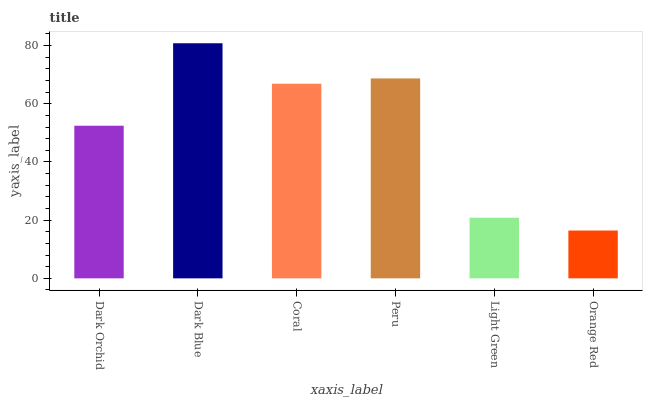Is Orange Red the minimum?
Answer yes or no. Yes. Is Dark Blue the maximum?
Answer yes or no. Yes. Is Coral the minimum?
Answer yes or no. No. Is Coral the maximum?
Answer yes or no. No. Is Dark Blue greater than Coral?
Answer yes or no. Yes. Is Coral less than Dark Blue?
Answer yes or no. Yes. Is Coral greater than Dark Blue?
Answer yes or no. No. Is Dark Blue less than Coral?
Answer yes or no. No. Is Coral the high median?
Answer yes or no. Yes. Is Dark Orchid the low median?
Answer yes or no. Yes. Is Dark Blue the high median?
Answer yes or no. No. Is Dark Blue the low median?
Answer yes or no. No. 